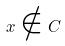Convert formula to latex. <formula><loc_0><loc_0><loc_500><loc_500>x \notin C</formula> 